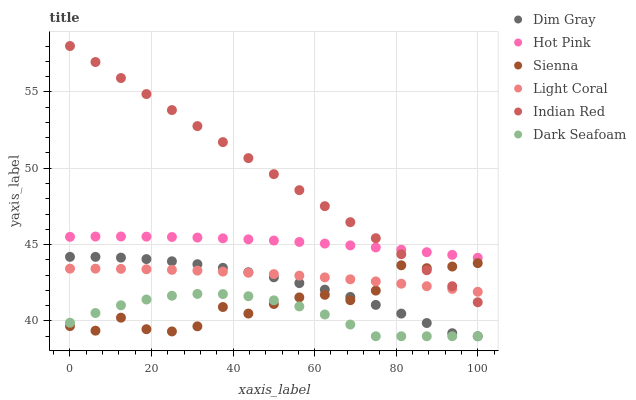Does Dark Seafoam have the minimum area under the curve?
Answer yes or no. Yes. Does Indian Red have the maximum area under the curve?
Answer yes or no. Yes. Does Dim Gray have the minimum area under the curve?
Answer yes or no. No. Does Dim Gray have the maximum area under the curve?
Answer yes or no. No. Is Indian Red the smoothest?
Answer yes or no. Yes. Is Sienna the roughest?
Answer yes or no. Yes. Is Dim Gray the smoothest?
Answer yes or no. No. Is Dim Gray the roughest?
Answer yes or no. No. Does Dim Gray have the lowest value?
Answer yes or no. Yes. Does Hot Pink have the lowest value?
Answer yes or no. No. Does Indian Red have the highest value?
Answer yes or no. Yes. Does Dim Gray have the highest value?
Answer yes or no. No. Is Dim Gray less than Hot Pink?
Answer yes or no. Yes. Is Hot Pink greater than Dark Seafoam?
Answer yes or no. Yes. Does Hot Pink intersect Indian Red?
Answer yes or no. Yes. Is Hot Pink less than Indian Red?
Answer yes or no. No. Is Hot Pink greater than Indian Red?
Answer yes or no. No. Does Dim Gray intersect Hot Pink?
Answer yes or no. No. 